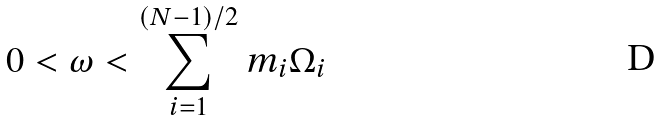<formula> <loc_0><loc_0><loc_500><loc_500>0 < \omega < \sum _ { i = 1 } ^ { ( N - 1 ) / 2 } m _ { i } \Omega _ { i }</formula> 